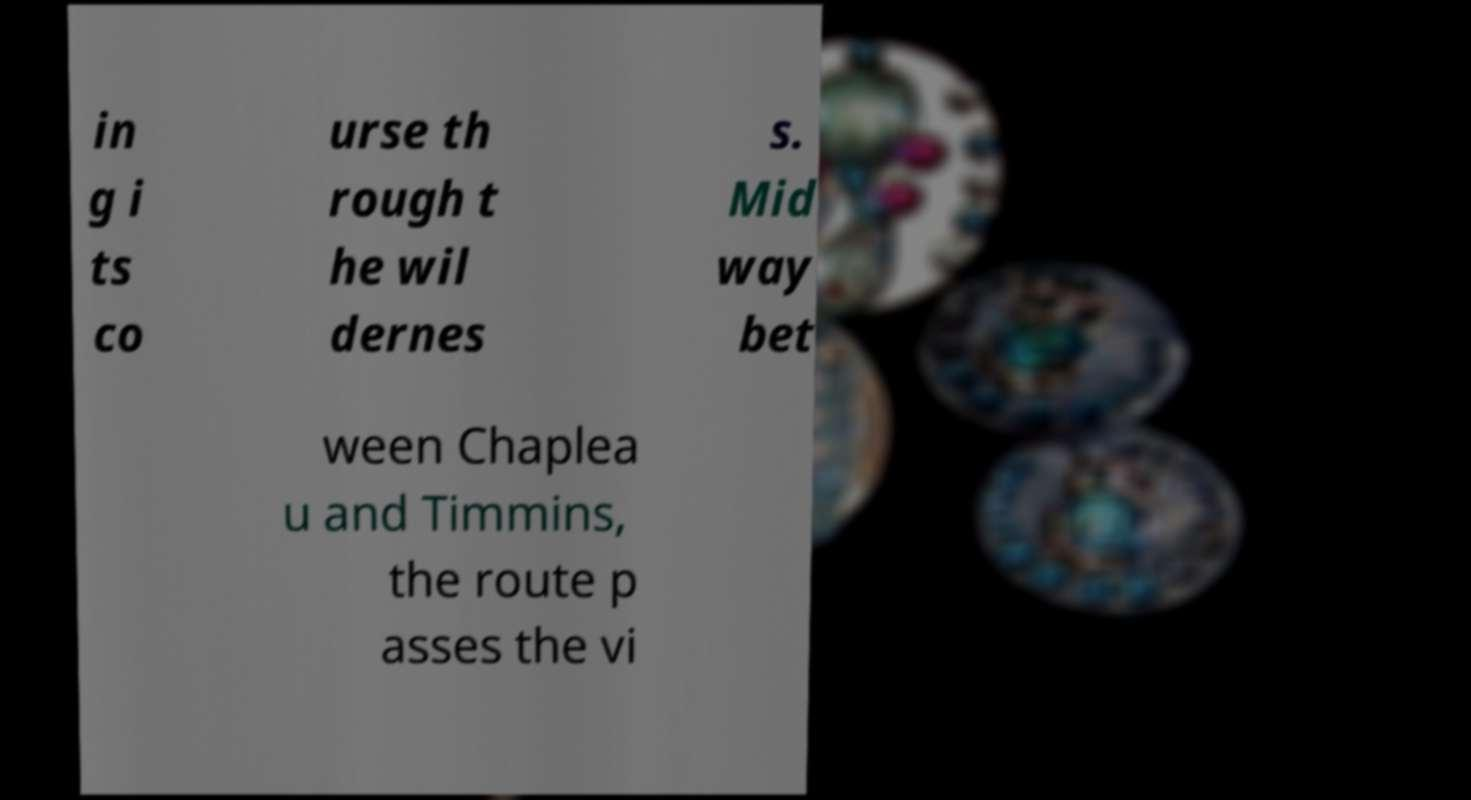For documentation purposes, I need the text within this image transcribed. Could you provide that? in g i ts co urse th rough t he wil dernes s. Mid way bet ween Chaplea u and Timmins, the route p asses the vi 